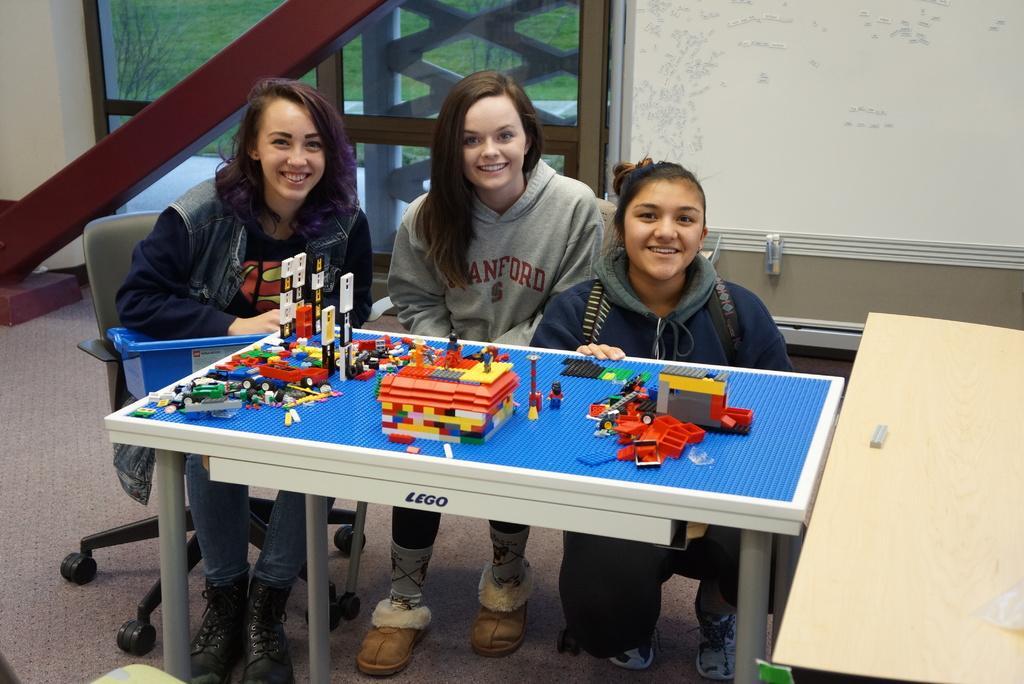Could you give a brief overview of what you see in this image? Three girls are posing to camera with a Lego table and Lego bricks on it. 